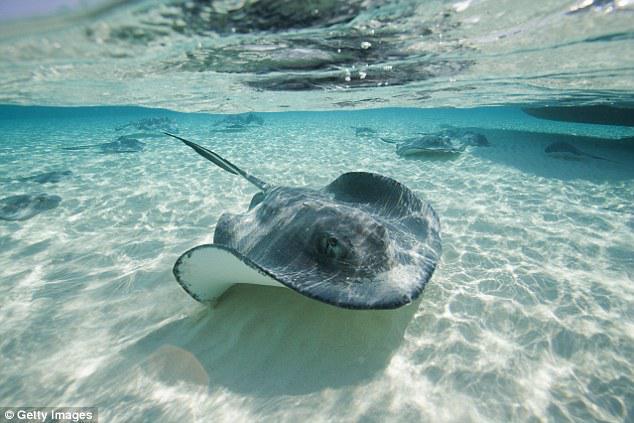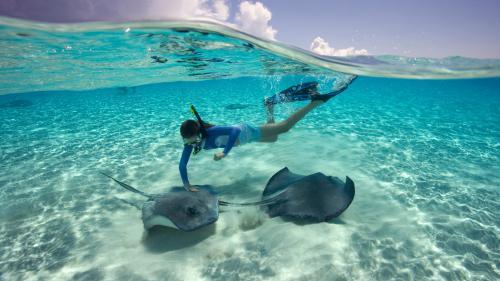The first image is the image on the left, the second image is the image on the right. Considering the images on both sides, is "In one image, at least one person is in the water interacting with a stingray, and a snorkel is visible." valid? Answer yes or no. Yes. The first image is the image on the left, the second image is the image on the right. For the images shown, is this caption "At least one human is in the ocean with the fish in one of the images." true? Answer yes or no. Yes. 